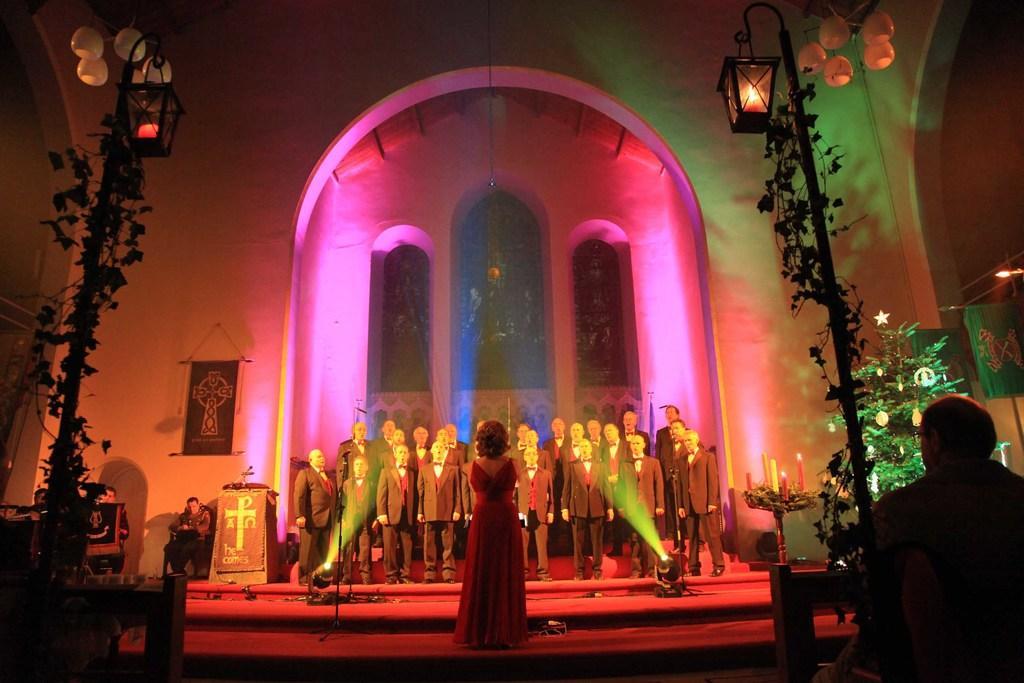Please provide a concise description of this image. In the image we can see there is a woman standing and in front of her there are other people standing. There are mice kept on the stand and there is a person standing near the podium. There is a man sitting on the chair and there are lamp poles and there are lightings. There is a man sitting. 